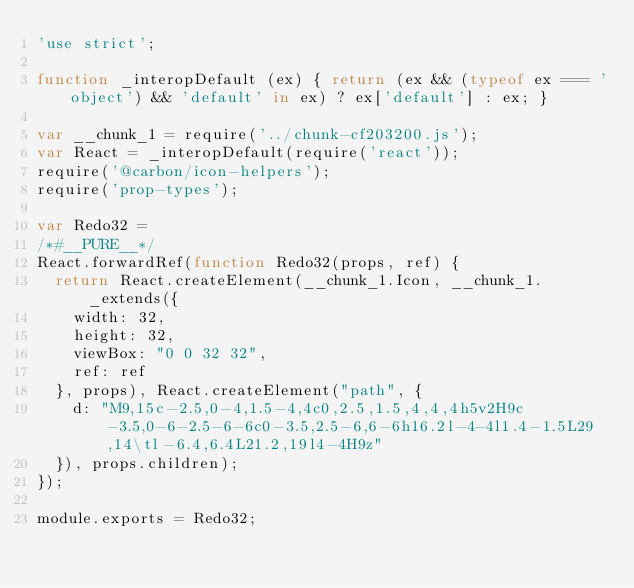Convert code to text. <code><loc_0><loc_0><loc_500><loc_500><_JavaScript_>'use strict';

function _interopDefault (ex) { return (ex && (typeof ex === 'object') && 'default' in ex) ? ex['default'] : ex; }

var __chunk_1 = require('../chunk-cf203200.js');
var React = _interopDefault(require('react'));
require('@carbon/icon-helpers');
require('prop-types');

var Redo32 =
/*#__PURE__*/
React.forwardRef(function Redo32(props, ref) {
  return React.createElement(__chunk_1.Icon, __chunk_1._extends({
    width: 32,
    height: 32,
    viewBox: "0 0 32 32",
    ref: ref
  }, props), React.createElement("path", {
    d: "M9,15c-2.5,0-4,1.5-4,4c0,2.5,1.5,4,4,4h5v2H9c-3.5,0-6-2.5-6-6c0-3.5,2.5-6,6-6h16.2l-4-4l1.4-1.5L29,14\tl-6.4,6.4L21.2,19l4-4H9z"
  }), props.children);
});

module.exports = Redo32;
</code> 